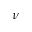Convert formula to latex. <formula><loc_0><loc_0><loc_500><loc_500>\nu</formula> 